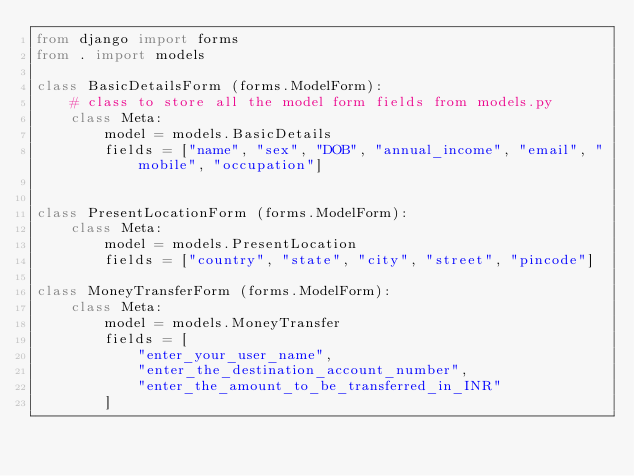Convert code to text. <code><loc_0><loc_0><loc_500><loc_500><_Python_>from django import forms
from . import models

class BasicDetailsForm (forms.ModelForm):
    # class to store all the model form fields from models.py
    class Meta:
        model = models.BasicDetails
        fields = ["name", "sex", "DOB", "annual_income", "email", "mobile", "occupation"]


class PresentLocationForm (forms.ModelForm):
    class Meta:
        model = models.PresentLocation
        fields = ["country", "state", "city", "street", "pincode"]

class MoneyTransferForm (forms.ModelForm):
    class Meta:
        model = models.MoneyTransfer
        fields = [
            "enter_your_user_name",
            "enter_the_destination_account_number", 
            "enter_the_amount_to_be_transferred_in_INR"
        ]
</code> 